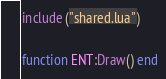<code> <loc_0><loc_0><loc_500><loc_500><_Lua_>include ("shared.lua")

function ENT:Draw() end</code> 